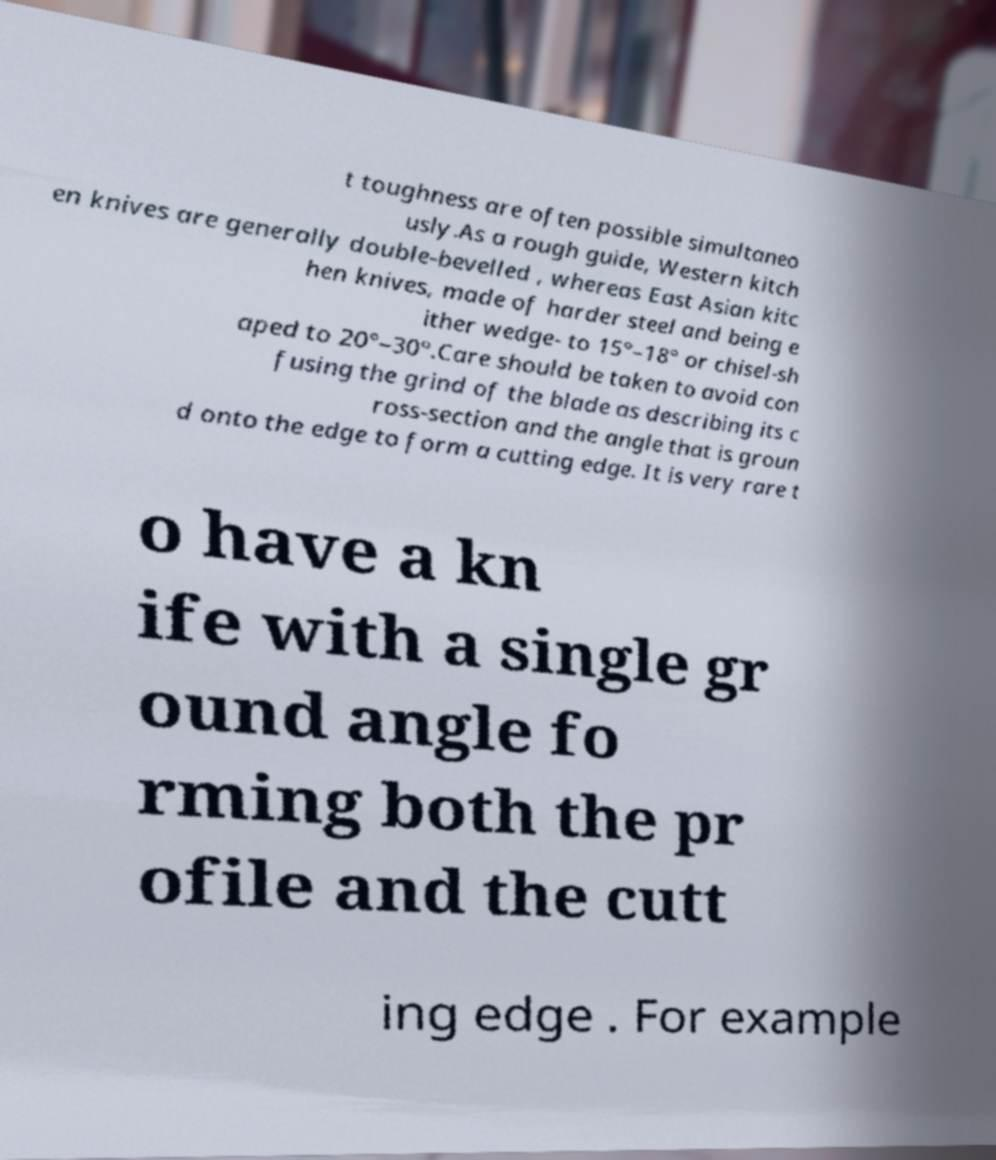Can you accurately transcribe the text from the provided image for me? t toughness are often possible simultaneo usly.As a rough guide, Western kitch en knives are generally double-bevelled , whereas East Asian kitc hen knives, made of harder steel and being e ither wedge- to 15°–18° or chisel-sh aped to 20°–30°.Care should be taken to avoid con fusing the grind of the blade as describing its c ross-section and the angle that is groun d onto the edge to form a cutting edge. It is very rare t o have a kn ife with a single gr ound angle fo rming both the pr ofile and the cutt ing edge . For example 